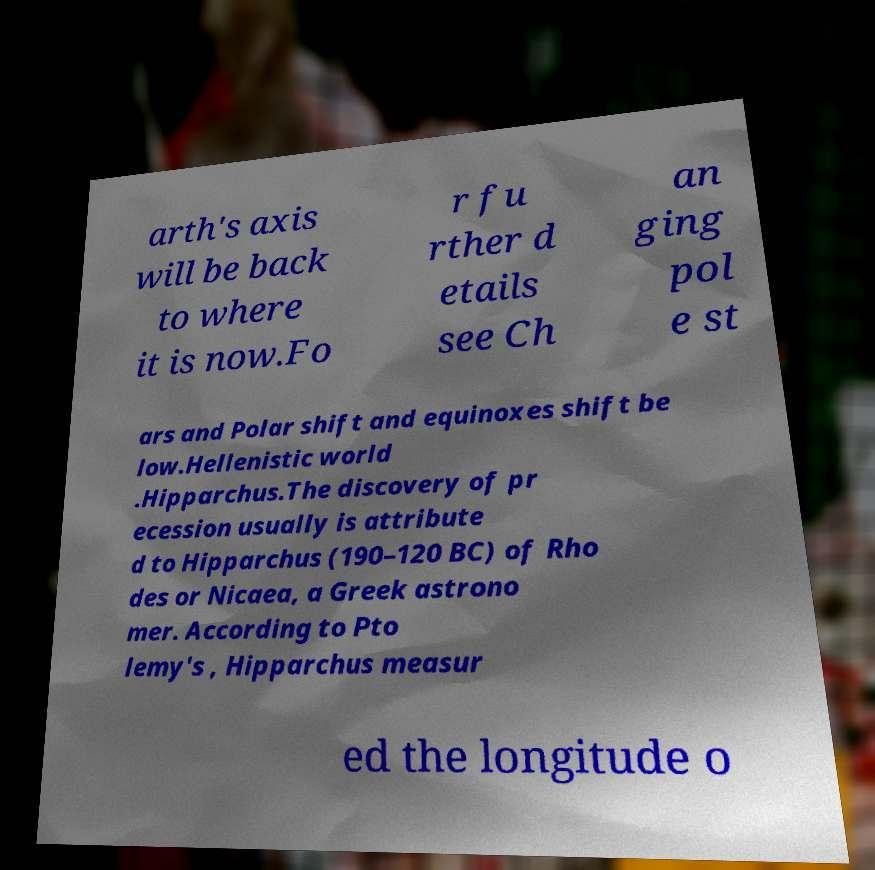Can you read and provide the text displayed in the image?This photo seems to have some interesting text. Can you extract and type it out for me? arth's axis will be back to where it is now.Fo r fu rther d etails see Ch an ging pol e st ars and Polar shift and equinoxes shift be low.Hellenistic world .Hipparchus.The discovery of pr ecession usually is attribute d to Hipparchus (190–120 BC) of Rho des or Nicaea, a Greek astrono mer. According to Pto lemy's , Hipparchus measur ed the longitude o 